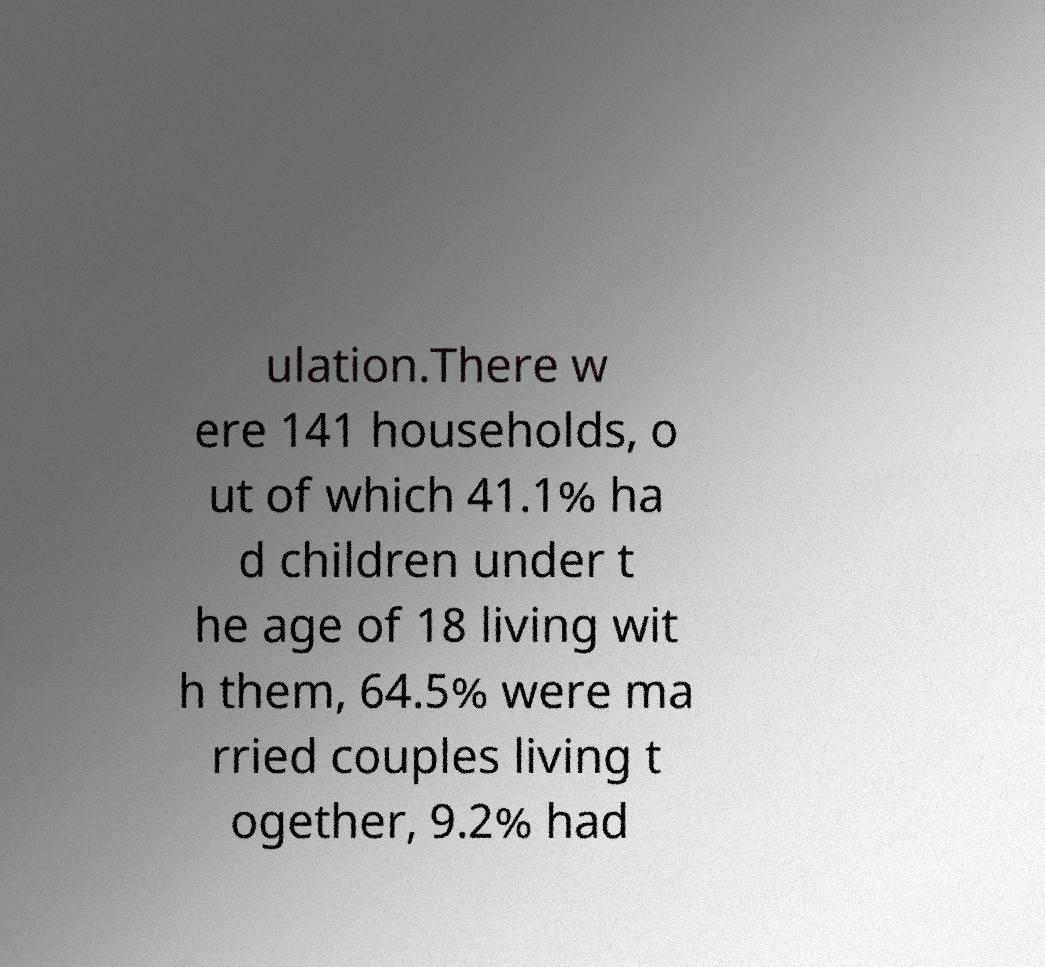I need the written content from this picture converted into text. Can you do that? ulation.There w ere 141 households, o ut of which 41.1% ha d children under t he age of 18 living wit h them, 64.5% were ma rried couples living t ogether, 9.2% had 